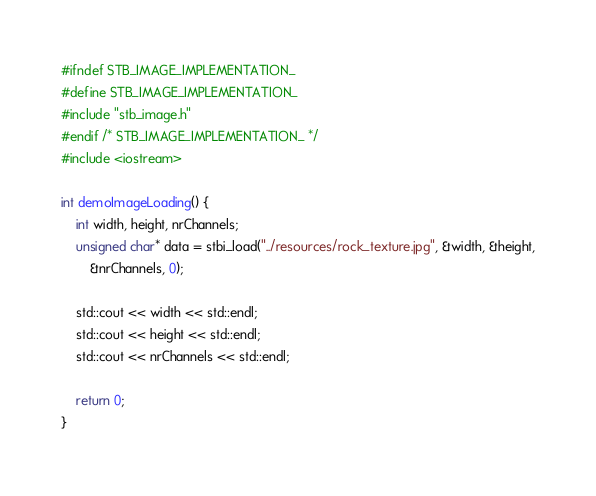<code> <loc_0><loc_0><loc_500><loc_500><_C++_>#ifndef STB_IMAGE_IMPLEMENTATION_
#define STB_IMAGE_IMPLEMENTATION_
#include "stb_image.h"
#endif /* STB_IMAGE_IMPLEMENTATION_ */
#include <iostream>

int demoImageLoading() {
	int width, height, nrChannels;
	unsigned char* data = stbi_load("../resources/rock_texture.jpg", &width, &height,
		&nrChannels, 0);

	std::cout << width << std::endl;
	std::cout << height << std::endl;
	std::cout << nrChannels << std::endl;
	
	return 0;
}</code> 